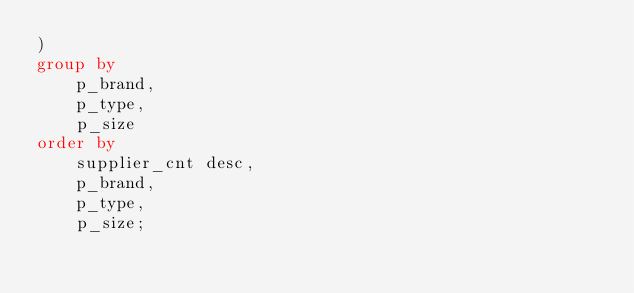Convert code to text. <code><loc_0><loc_0><loc_500><loc_500><_SQL_>)
group by
    p_brand,
    p_type,
    p_size
order by
    supplier_cnt desc,
    p_brand,
    p_type,
    p_size;
</code> 